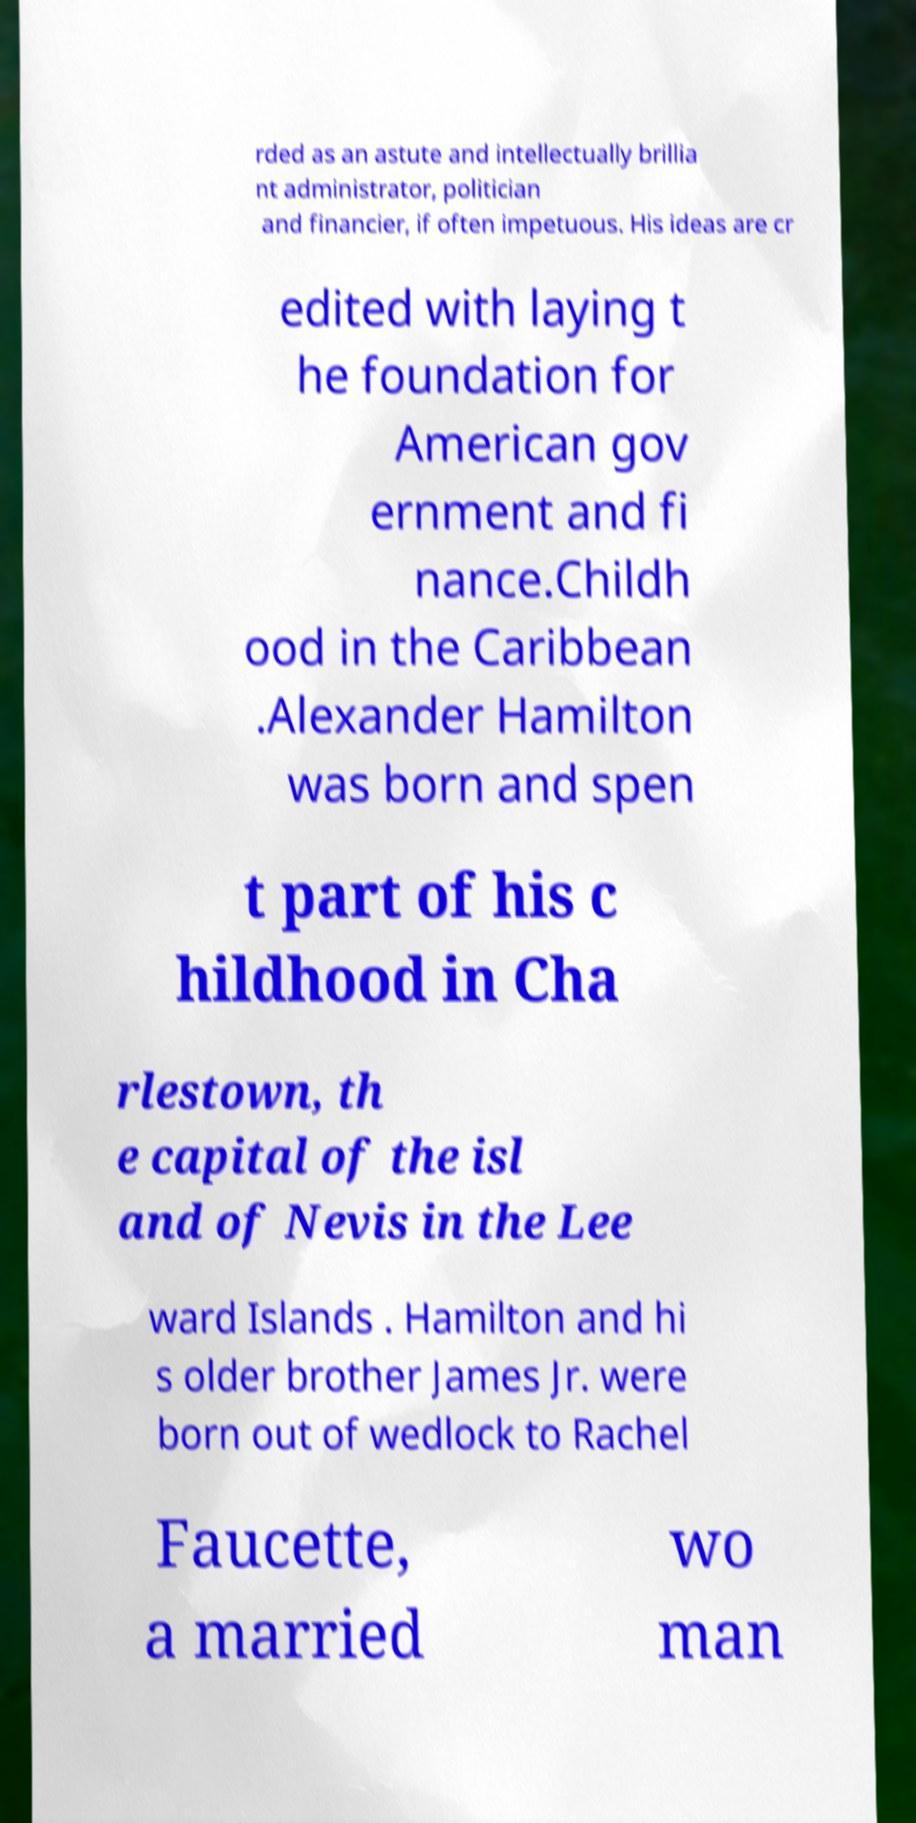For documentation purposes, I need the text within this image transcribed. Could you provide that? rded as an astute and intellectually brillia nt administrator, politician and financier, if often impetuous. His ideas are cr edited with laying t he foundation for American gov ernment and fi nance.Childh ood in the Caribbean .Alexander Hamilton was born and spen t part of his c hildhood in Cha rlestown, th e capital of the isl and of Nevis in the Lee ward Islands . Hamilton and hi s older brother James Jr. were born out of wedlock to Rachel Faucette, a married wo man 